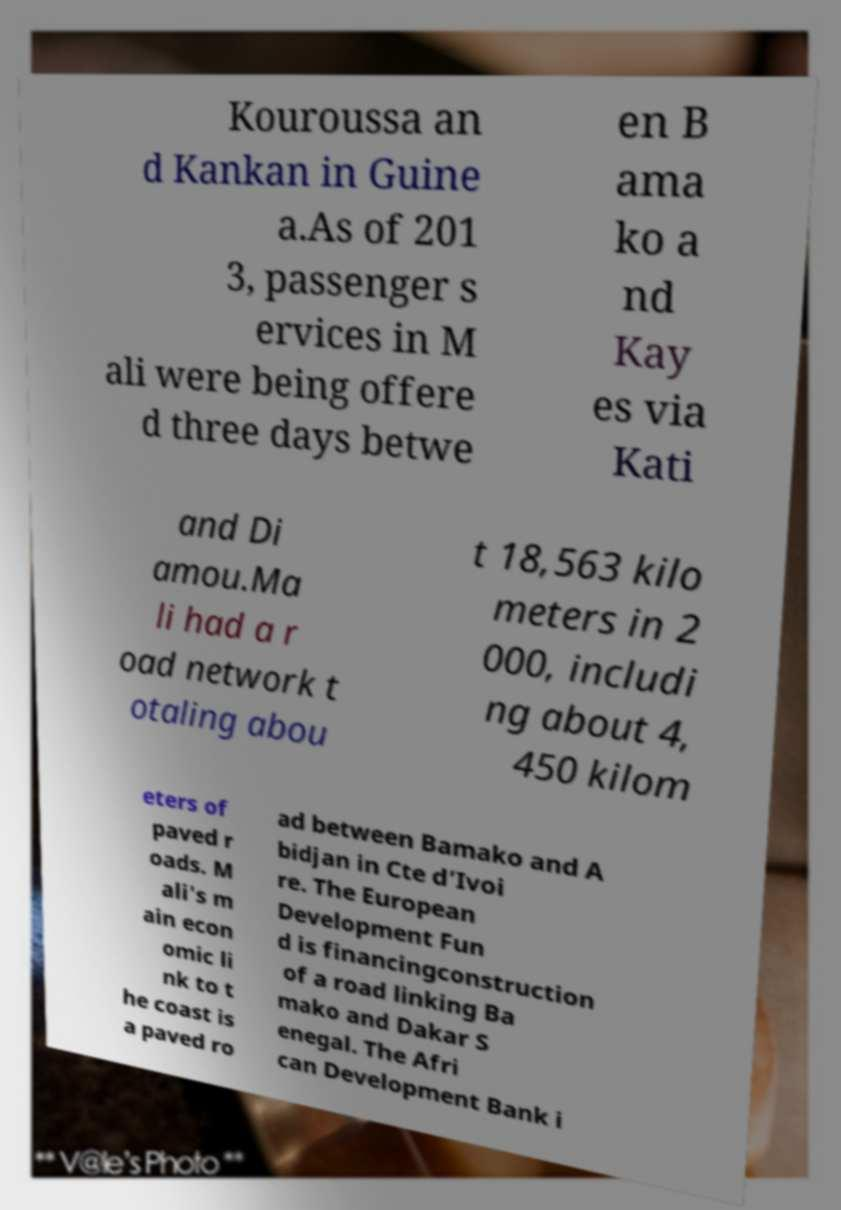For documentation purposes, I need the text within this image transcribed. Could you provide that? Kouroussa an d Kankan in Guine a.As of 201 3, passenger s ervices in M ali were being offere d three days betwe en B ama ko a nd Kay es via Kati and Di amou.Ma li had a r oad network t otaling abou t 18,563 kilo meters in 2 000, includi ng about 4, 450 kilom eters of paved r oads. M ali's m ain econ omic li nk to t he coast is a paved ro ad between Bamako and A bidjan in Cte d’Ivoi re. The European Development Fun d is financingconstruction of a road linking Ba mako and Dakar S enegal. The Afri can Development Bank i 